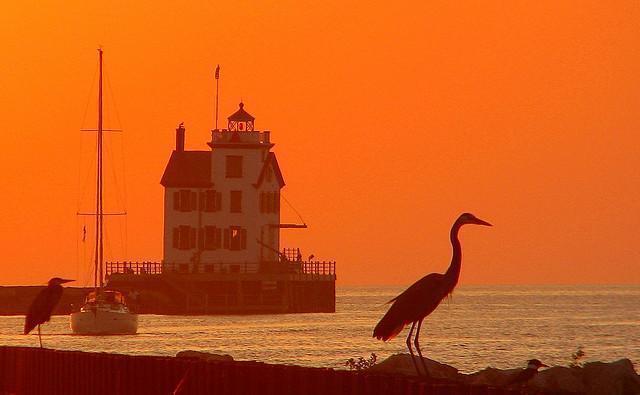Which animal is most similar to the animal on the right?
Answer the question by selecting the correct answer among the 4 following choices.
Options: Manx, echidna, egret, salamander. Egret. What are the birds in front of?
Select the accurate answer and provide justification: `Answer: choice
Rationale: srationale.`
Options: Baby, car, cow, house. Answer: house.
Rationale: The birds are in front of a large house that sits next to the water. 